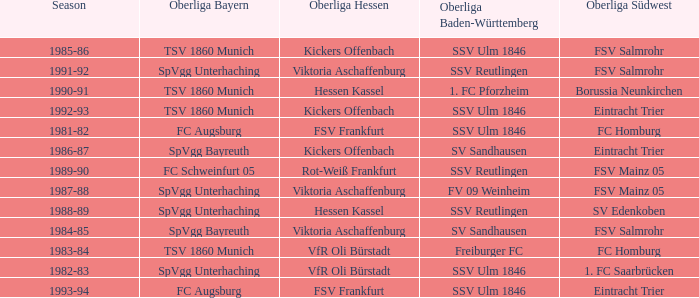Which Oberliga Südwest has an Oberliga Bayern of fc schweinfurt 05? FSV Mainz 05. 